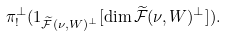Convert formula to latex. <formula><loc_0><loc_0><loc_500><loc_500>\pi ^ { \perp } _ { ! } ( 1 _ { \widetilde { \mathcal { F } } ( \nu , W ) ^ { \perp } } [ \dim \widetilde { \mathcal { F } } ( \nu , W ) ^ { \perp } ] ) .</formula> 